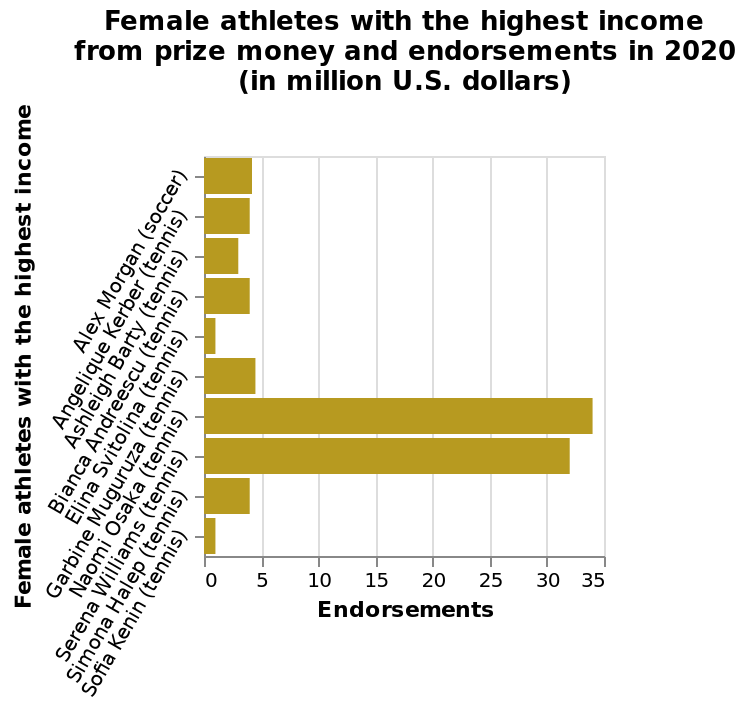<image>
Who are the two athletes who are significantly ahead of all others in the chart?  Naomi Osaka and Serena Williams are the two athletes who are significantly ahead of all others in the chart. Among tennis players and soccer players, who is leading in the chart? Among tennis players and soccer players, Naomi Osaka and Serena Williams are leading in the chart. Who are the two athletes mentioned in the figure?  The two athletes mentioned in the figure are Alex Morgan (soccer) and Sofia Kenin (tennis). 